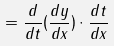Convert formula to latex. <formula><loc_0><loc_0><loc_500><loc_500>= \frac { d } { d t } ( \frac { d y } { d x } ) \cdot \frac { d t } { d x }</formula> 